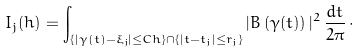<formula> <loc_0><loc_0><loc_500><loc_500>I _ { j } ( h ) = \int _ { \{ | \gamma ( t ) - \xi _ { j } | \leq C h \} \cap \{ | t - t _ { j } | \leq r _ { j } \} } | B \left ( \gamma ( t ) \right ) | ^ { 2 } \, \frac { d t } { 2 \pi } \, \cdot</formula> 